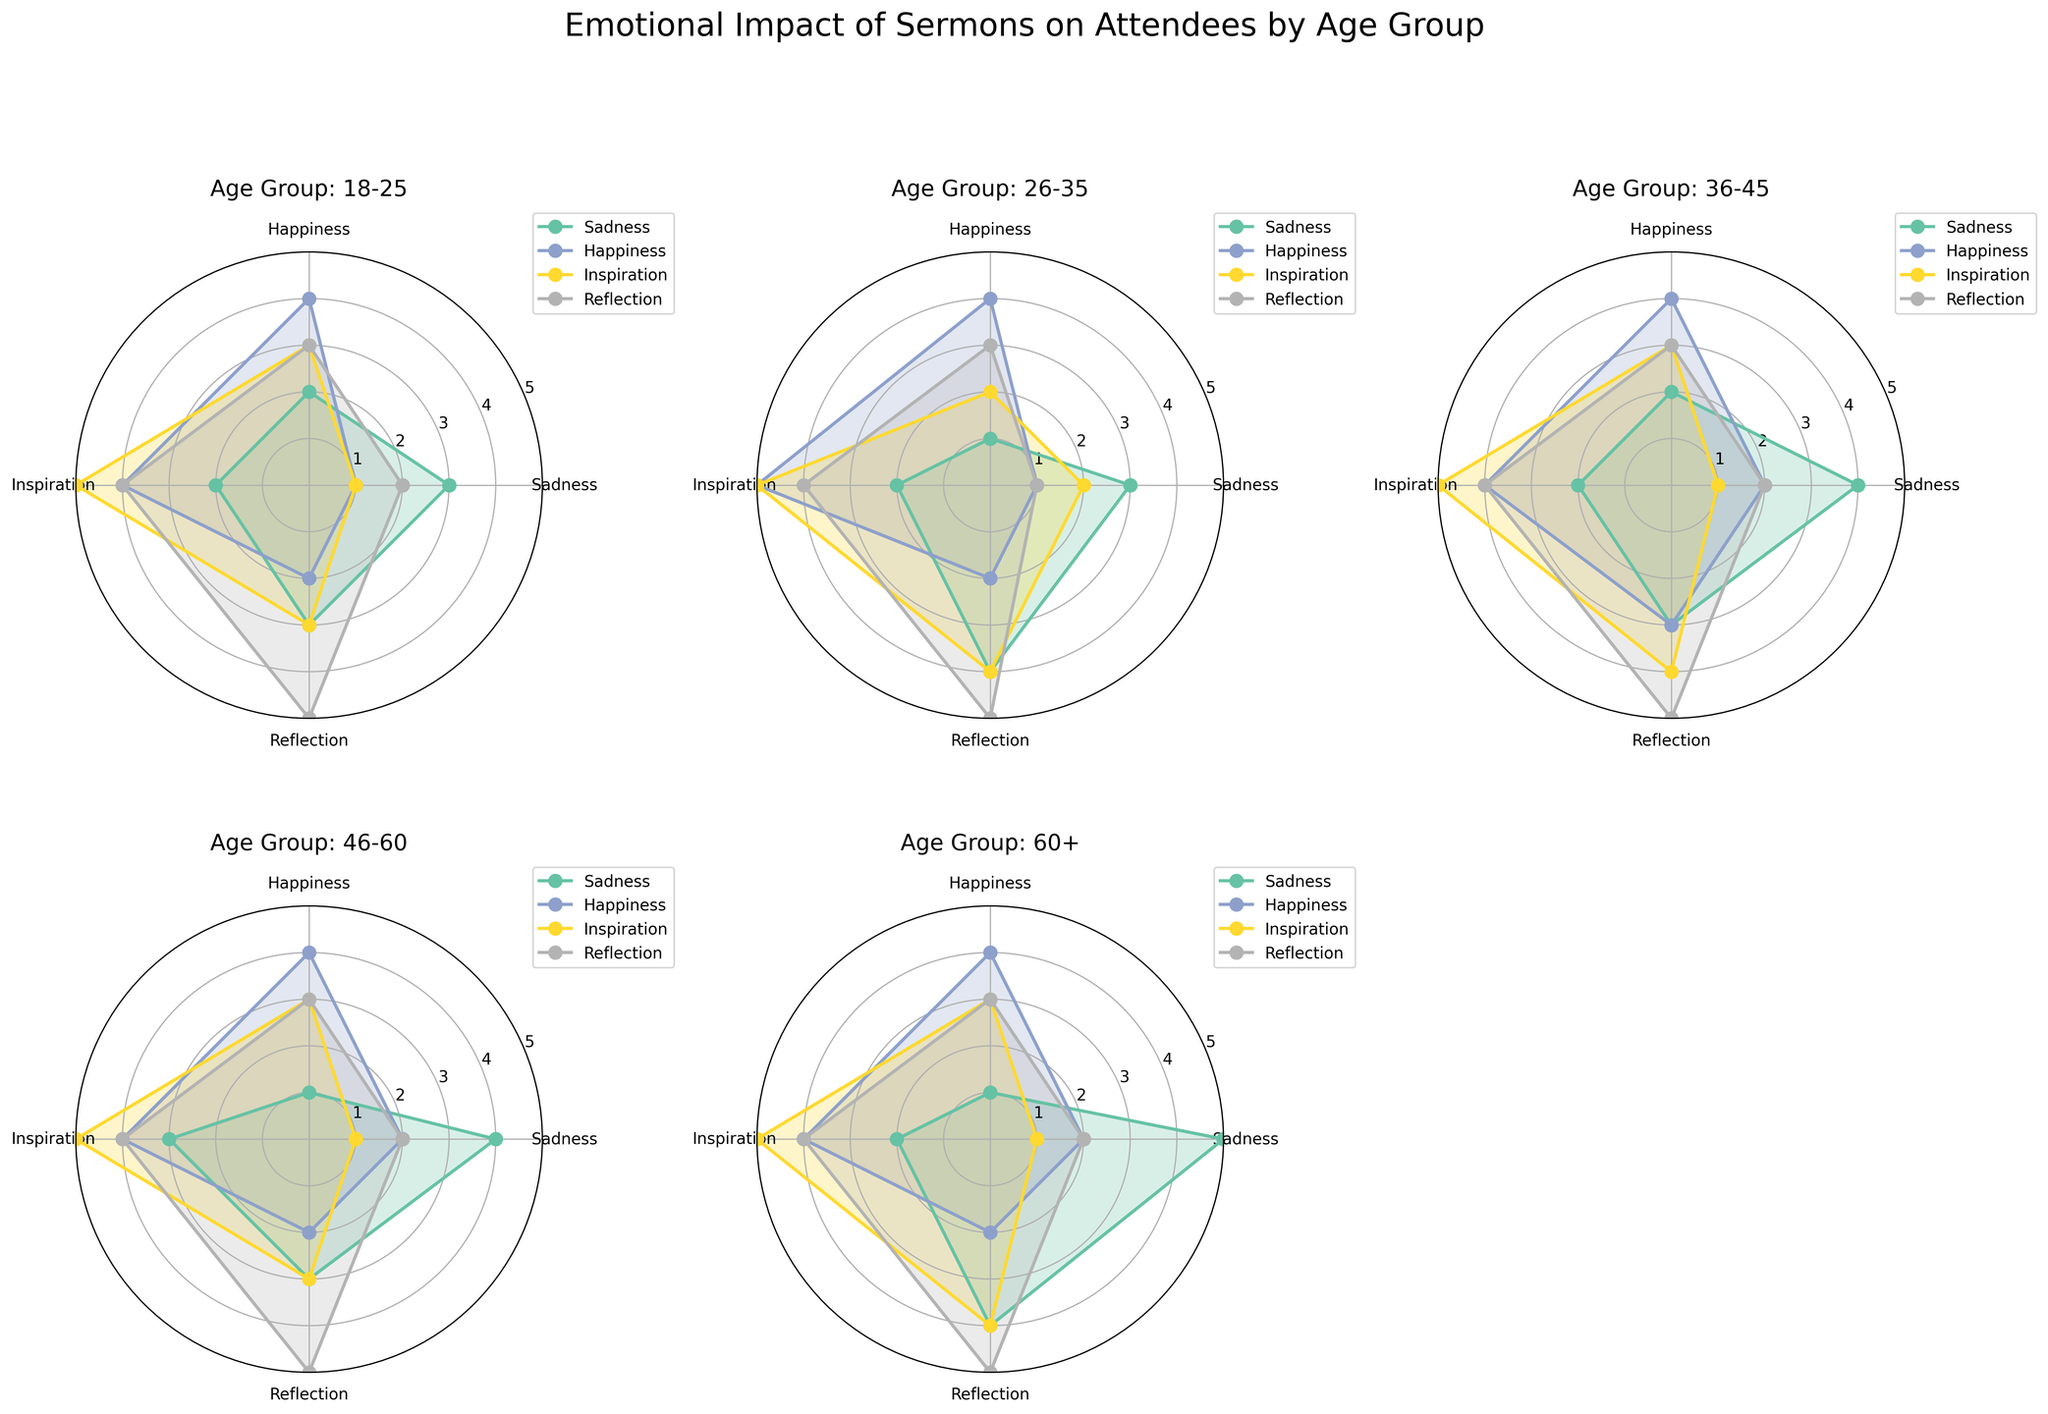What's the title of the figure? The title is displayed at the top center of the figure and reads "Emotional Impact of Sermons on Attendees by Age Group."
Answer: Emotional Impact of Sermons on Attendees by Age Group Which age group shows the highest average intensity for the emotion 'Inspiration'? By looking at the radial plots for Inspiration across each subplot, the highest peak value can be seen in the age group 26-35.
Answer: 26-35 How does the emotional impact of Inspiration compare between the 18-25 and 60+ age groups? Visual comparison of the 'Inspiration' line shows that the values for 'Inspiration' are similar in both subplots, but slightly higher in the 18-25 group than the 60+ group.
Answer: Higher in 18-25 Which emotion has the highest average intensity in the 46-60 age group? Checking the radial plot for the 46-60 age group, the highest peak is for 'Inspiration' with average intensities of 4.4.
Answer: Inspiration Does the emotion 'Sadness' show a consistent pattern across all age groups? Upon inspecting the plots for 'Sadness' across all subplots, 'Sadness' generally has lower values and remains between the range of 2 to 3 in each age group.
Answer: Yes For the age group 36-45, which emotions reach an average intensity of 4 or higher? Observing the 36-45 age group subplot, both 'Inspiration' and 'Reflection' cross the 4 intensity mark.
Answer: Inspiration, Reflection What is the general trend for 'Happiness' as age increases? By examining the 'Happiness' lines across all subplots, 'Happiness' peaks around the 26-35 age group and then slightly decreases with increasing age.
Answer: Decreasing with age In which age group is 'Reflection' most impactful? The age group 60+ has the highest peak for 'Reflection' with the average intensity of 4.3.
Answer: 60+ Compare the 'Sadness' levels between age groups 18-25 and 46-60. In both subplots, 'Sadness' values are quite close, with 2.5 average intensity in 18-25 and 2.9 in 46-60.
Answer: Higher in 46-60 What is the average intensity of 'Happiness' in the age group 26-35? Looking at the radial plot for this age group, the 'Happiness' values show an average intensity of 3.9.
Answer: 3.9 